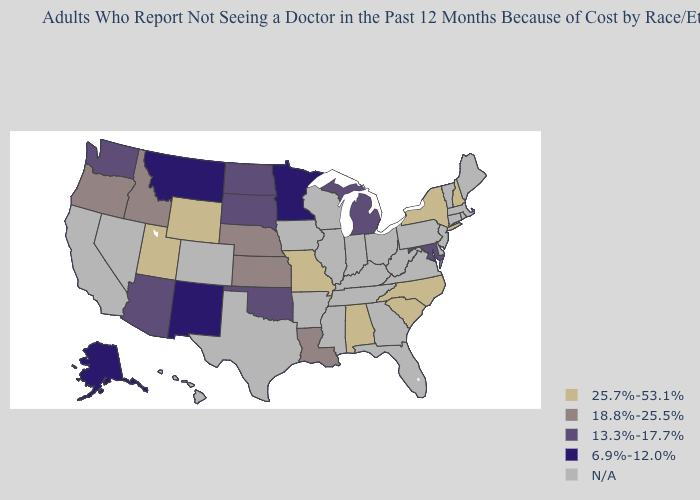Name the states that have a value in the range 25.7%-53.1%?
Concise answer only. Alabama, Missouri, New Hampshire, New York, North Carolina, South Carolina, Utah, Wyoming. What is the value of Alabama?
Concise answer only. 25.7%-53.1%. Which states have the highest value in the USA?
Concise answer only. Alabama, Missouri, New Hampshire, New York, North Carolina, South Carolina, Utah, Wyoming. What is the highest value in the South ?
Concise answer only. 25.7%-53.1%. Name the states that have a value in the range 18.8%-25.5%?
Be succinct. Idaho, Kansas, Louisiana, Nebraska, Oregon. What is the highest value in the MidWest ?
Quick response, please. 25.7%-53.1%. What is the lowest value in states that border Iowa?
Be succinct. 6.9%-12.0%. Which states have the lowest value in the USA?
Short answer required. Alaska, Minnesota, Montana, New Mexico. Name the states that have a value in the range N/A?
Keep it brief. Arkansas, California, Colorado, Connecticut, Delaware, Florida, Georgia, Hawaii, Illinois, Indiana, Iowa, Kentucky, Maine, Massachusetts, Mississippi, Nevada, New Jersey, Ohio, Pennsylvania, Rhode Island, Tennessee, Texas, Vermont, Virginia, West Virginia, Wisconsin. What is the value of Pennsylvania?
Keep it brief. N/A. How many symbols are there in the legend?
Concise answer only. 5. Among the states that border Connecticut , which have the lowest value?
Concise answer only. New York. Name the states that have a value in the range 13.3%-17.7%?
Short answer required. Arizona, Maryland, Michigan, North Dakota, Oklahoma, South Dakota, Washington. 